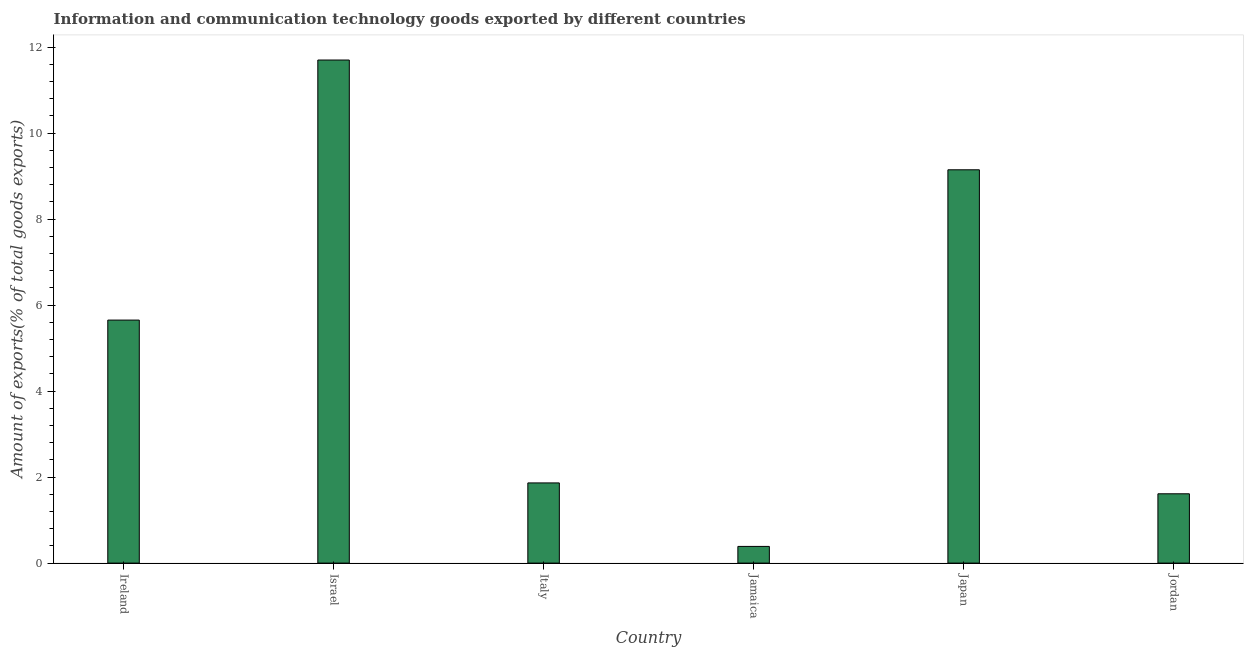What is the title of the graph?
Your answer should be very brief. Information and communication technology goods exported by different countries. What is the label or title of the Y-axis?
Ensure brevity in your answer.  Amount of exports(% of total goods exports). What is the amount of ict goods exports in Japan?
Your answer should be compact. 9.15. Across all countries, what is the maximum amount of ict goods exports?
Your answer should be very brief. 11.7. Across all countries, what is the minimum amount of ict goods exports?
Keep it short and to the point. 0.39. In which country was the amount of ict goods exports minimum?
Provide a short and direct response. Jamaica. What is the sum of the amount of ict goods exports?
Provide a succinct answer. 30.37. What is the difference between the amount of ict goods exports in Jamaica and Jordan?
Your response must be concise. -1.22. What is the average amount of ict goods exports per country?
Offer a very short reply. 5.06. What is the median amount of ict goods exports?
Make the answer very short. 3.76. What is the ratio of the amount of ict goods exports in Israel to that in Japan?
Ensure brevity in your answer.  1.28. Is the amount of ict goods exports in Ireland less than that in Jamaica?
Offer a terse response. No. Is the difference between the amount of ict goods exports in Ireland and Israel greater than the difference between any two countries?
Your answer should be very brief. No. What is the difference between the highest and the second highest amount of ict goods exports?
Your response must be concise. 2.55. Is the sum of the amount of ict goods exports in Israel and Jamaica greater than the maximum amount of ict goods exports across all countries?
Your answer should be very brief. Yes. What is the difference between the highest and the lowest amount of ict goods exports?
Keep it short and to the point. 11.31. How many bars are there?
Give a very brief answer. 6. Are all the bars in the graph horizontal?
Keep it short and to the point. No. What is the difference between two consecutive major ticks on the Y-axis?
Offer a very short reply. 2. Are the values on the major ticks of Y-axis written in scientific E-notation?
Your answer should be very brief. No. What is the Amount of exports(% of total goods exports) of Ireland?
Ensure brevity in your answer.  5.65. What is the Amount of exports(% of total goods exports) of Israel?
Offer a very short reply. 11.7. What is the Amount of exports(% of total goods exports) of Italy?
Your answer should be compact. 1.86. What is the Amount of exports(% of total goods exports) in Jamaica?
Provide a short and direct response. 0.39. What is the Amount of exports(% of total goods exports) in Japan?
Give a very brief answer. 9.15. What is the Amount of exports(% of total goods exports) of Jordan?
Offer a terse response. 1.61. What is the difference between the Amount of exports(% of total goods exports) in Ireland and Israel?
Offer a very short reply. -6.05. What is the difference between the Amount of exports(% of total goods exports) in Ireland and Italy?
Make the answer very short. 3.79. What is the difference between the Amount of exports(% of total goods exports) in Ireland and Jamaica?
Give a very brief answer. 5.26. What is the difference between the Amount of exports(% of total goods exports) in Ireland and Japan?
Give a very brief answer. -3.5. What is the difference between the Amount of exports(% of total goods exports) in Ireland and Jordan?
Keep it short and to the point. 4.04. What is the difference between the Amount of exports(% of total goods exports) in Israel and Italy?
Give a very brief answer. 9.84. What is the difference between the Amount of exports(% of total goods exports) in Israel and Jamaica?
Provide a succinct answer. 11.31. What is the difference between the Amount of exports(% of total goods exports) in Israel and Japan?
Give a very brief answer. 2.55. What is the difference between the Amount of exports(% of total goods exports) in Israel and Jordan?
Provide a short and direct response. 10.09. What is the difference between the Amount of exports(% of total goods exports) in Italy and Jamaica?
Make the answer very short. 1.48. What is the difference between the Amount of exports(% of total goods exports) in Italy and Japan?
Your answer should be very brief. -7.28. What is the difference between the Amount of exports(% of total goods exports) in Italy and Jordan?
Your response must be concise. 0.25. What is the difference between the Amount of exports(% of total goods exports) in Jamaica and Japan?
Your answer should be compact. -8.76. What is the difference between the Amount of exports(% of total goods exports) in Jamaica and Jordan?
Keep it short and to the point. -1.22. What is the difference between the Amount of exports(% of total goods exports) in Japan and Jordan?
Make the answer very short. 7.54. What is the ratio of the Amount of exports(% of total goods exports) in Ireland to that in Israel?
Your response must be concise. 0.48. What is the ratio of the Amount of exports(% of total goods exports) in Ireland to that in Italy?
Offer a very short reply. 3.03. What is the ratio of the Amount of exports(% of total goods exports) in Ireland to that in Jamaica?
Give a very brief answer. 14.57. What is the ratio of the Amount of exports(% of total goods exports) in Ireland to that in Japan?
Your answer should be compact. 0.62. What is the ratio of the Amount of exports(% of total goods exports) in Ireland to that in Jordan?
Keep it short and to the point. 3.51. What is the ratio of the Amount of exports(% of total goods exports) in Israel to that in Italy?
Provide a short and direct response. 6.28. What is the ratio of the Amount of exports(% of total goods exports) in Israel to that in Jamaica?
Offer a very short reply. 30.16. What is the ratio of the Amount of exports(% of total goods exports) in Israel to that in Japan?
Your response must be concise. 1.28. What is the ratio of the Amount of exports(% of total goods exports) in Israel to that in Jordan?
Offer a very short reply. 7.26. What is the ratio of the Amount of exports(% of total goods exports) in Italy to that in Jamaica?
Keep it short and to the point. 4.81. What is the ratio of the Amount of exports(% of total goods exports) in Italy to that in Japan?
Your response must be concise. 0.2. What is the ratio of the Amount of exports(% of total goods exports) in Italy to that in Jordan?
Make the answer very short. 1.16. What is the ratio of the Amount of exports(% of total goods exports) in Jamaica to that in Japan?
Your answer should be very brief. 0.04. What is the ratio of the Amount of exports(% of total goods exports) in Jamaica to that in Jordan?
Ensure brevity in your answer.  0.24. What is the ratio of the Amount of exports(% of total goods exports) in Japan to that in Jordan?
Offer a very short reply. 5.67. 